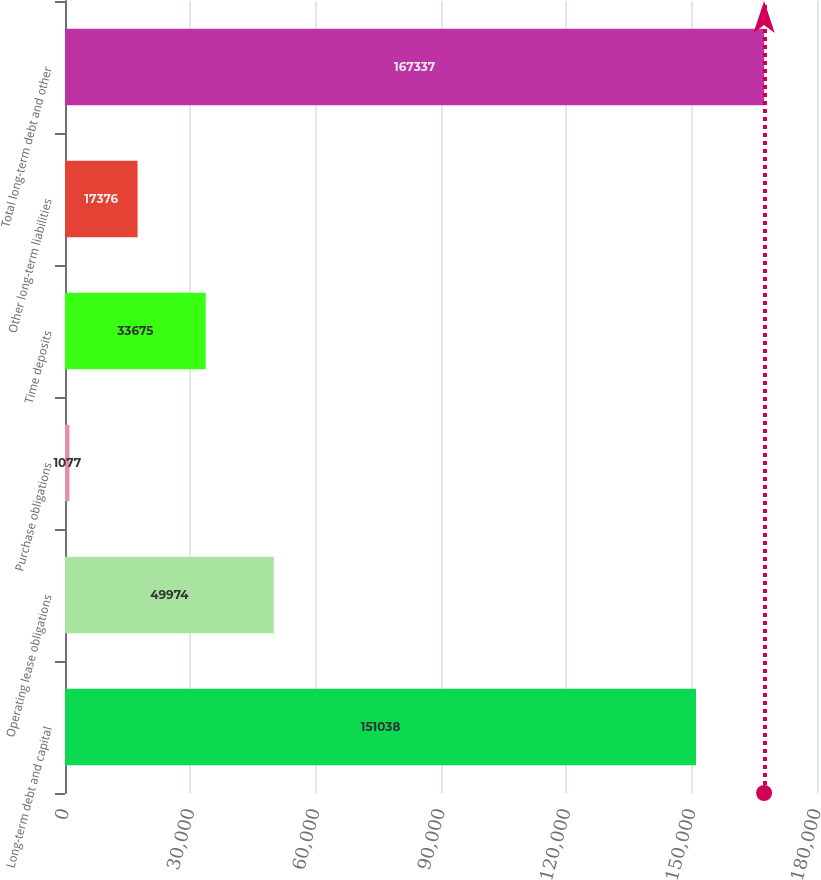Convert chart to OTSL. <chart><loc_0><loc_0><loc_500><loc_500><bar_chart><fcel>Long-term debt and capital<fcel>Operating lease obligations<fcel>Purchase obligations<fcel>Time deposits<fcel>Other long-term liabilities<fcel>Total long-term debt and other<nl><fcel>151038<fcel>49974<fcel>1077<fcel>33675<fcel>17376<fcel>167337<nl></chart> 